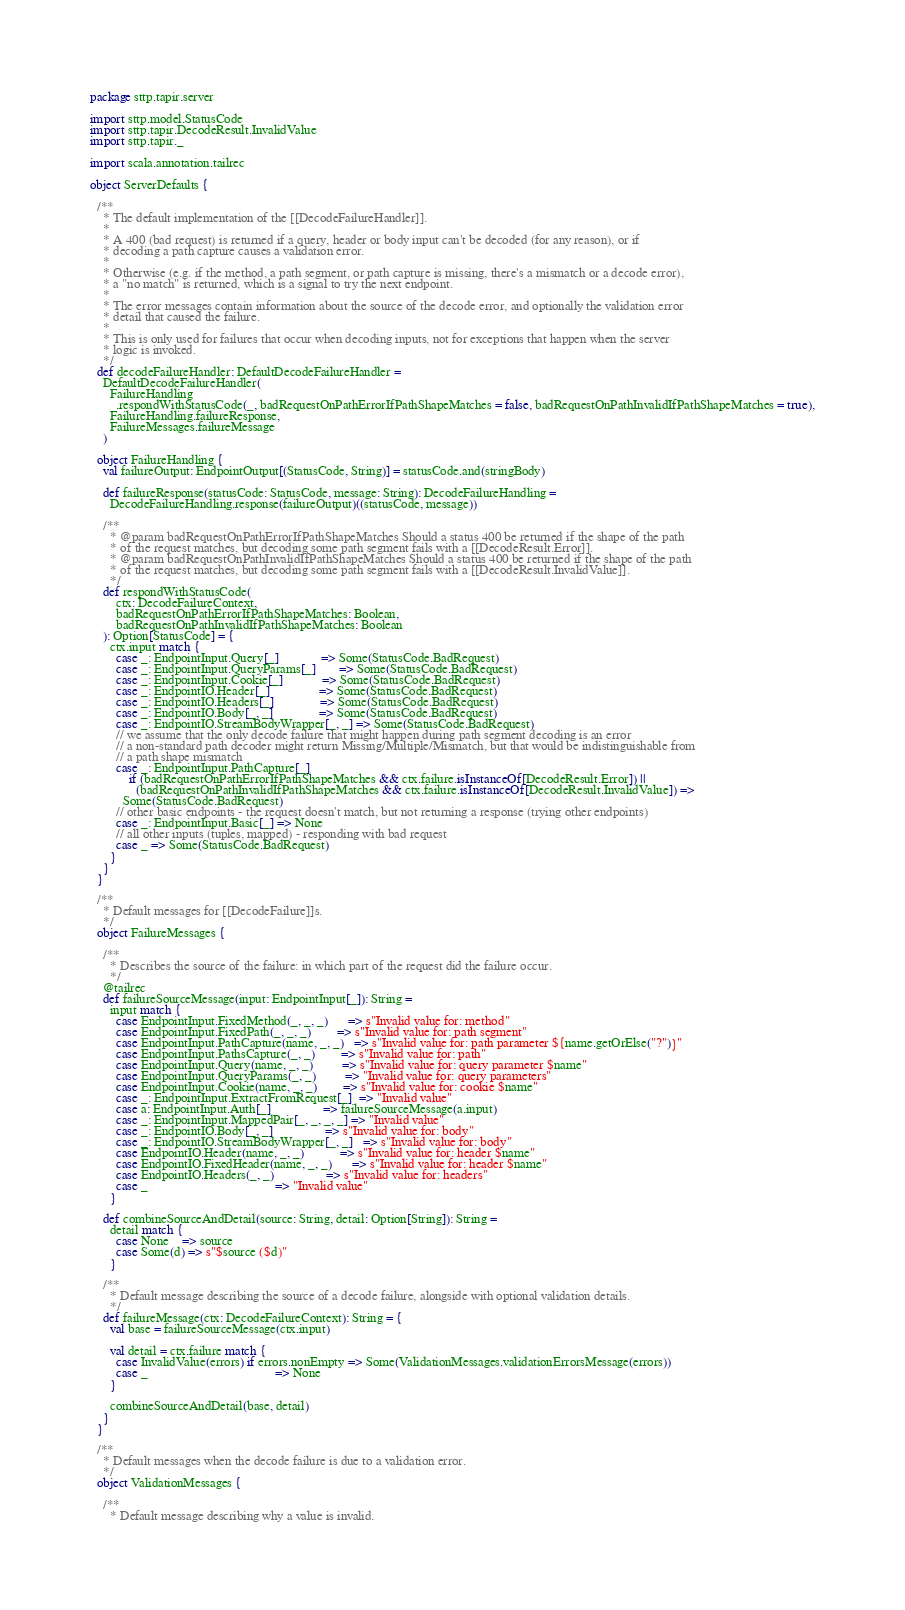Convert code to text. <code><loc_0><loc_0><loc_500><loc_500><_Scala_>package sttp.tapir.server

import sttp.model.StatusCode
import sttp.tapir.DecodeResult.InvalidValue
import sttp.tapir._

import scala.annotation.tailrec

object ServerDefaults {

  /**
    * The default implementation of the [[DecodeFailureHandler]].
    *
    * A 400 (bad request) is returned if a query, header or body input can't be decoded (for any reason), or if
    * decoding a path capture causes a validation error.
    *
    * Otherwise (e.g. if the method, a path segment, or path capture is missing, there's a mismatch or a decode error),
    * a "no match" is returned, which is a signal to try the next endpoint.
    *
    * The error messages contain information about the source of the decode error, and optionally the validation error
    * detail that caused the failure.
    *
    * This is only used for failures that occur when decoding inputs, not for exceptions that happen when the server
    * logic is invoked.
    */
  def decodeFailureHandler: DefaultDecodeFailureHandler =
    DefaultDecodeFailureHandler(
      FailureHandling
        .respondWithStatusCode(_, badRequestOnPathErrorIfPathShapeMatches = false, badRequestOnPathInvalidIfPathShapeMatches = true),
      FailureHandling.failureResponse,
      FailureMessages.failureMessage
    )

  object FailureHandling {
    val failureOutput: EndpointOutput[(StatusCode, String)] = statusCode.and(stringBody)

    def failureResponse(statusCode: StatusCode, message: String): DecodeFailureHandling =
      DecodeFailureHandling.response(failureOutput)((statusCode, message))

    /**
      * @param badRequestOnPathErrorIfPathShapeMatches Should a status 400 be returned if the shape of the path
      * of the request matches, but decoding some path segment fails with a [[DecodeResult.Error]].
      * @param badRequestOnPathInvalidIfPathShapeMatches Should a status 400 be returned if the shape of the path
      * of the request matches, but decoding some path segment fails with a [[DecodeResult.InvalidValue]].
      */
    def respondWithStatusCode(
        ctx: DecodeFailureContext,
        badRequestOnPathErrorIfPathShapeMatches: Boolean,
        badRequestOnPathInvalidIfPathShapeMatches: Boolean
    ): Option[StatusCode] = {
      ctx.input match {
        case _: EndpointInput.Query[_]             => Some(StatusCode.BadRequest)
        case _: EndpointInput.QueryParams[_]       => Some(StatusCode.BadRequest)
        case _: EndpointInput.Cookie[_]            => Some(StatusCode.BadRequest)
        case _: EndpointIO.Header[_]               => Some(StatusCode.BadRequest)
        case _: EndpointIO.Headers[_]              => Some(StatusCode.BadRequest)
        case _: EndpointIO.Body[_, _]              => Some(StatusCode.BadRequest)
        case _: EndpointIO.StreamBodyWrapper[_, _] => Some(StatusCode.BadRequest)
        // we assume that the only decode failure that might happen during path segment decoding is an error
        // a non-standard path decoder might return Missing/Multiple/Mismatch, but that would be indistinguishable from
        // a path shape mismatch
        case _: EndpointInput.PathCapture[_]
            if (badRequestOnPathErrorIfPathShapeMatches && ctx.failure.isInstanceOf[DecodeResult.Error]) ||
              (badRequestOnPathInvalidIfPathShapeMatches && ctx.failure.isInstanceOf[DecodeResult.InvalidValue]) =>
          Some(StatusCode.BadRequest)
        // other basic endpoints - the request doesn't match, but not returning a response (trying other endpoints)
        case _: EndpointInput.Basic[_] => None
        // all other inputs (tuples, mapped) - responding with bad request
        case _ => Some(StatusCode.BadRequest)
      }
    }
  }

  /**
    * Default messages for [[DecodeFailure]]s.
    */
  object FailureMessages {

    /**
      * Describes the source of the failure: in which part of the request did the failure occur.
      */
    @tailrec
    def failureSourceMessage(input: EndpointInput[_]): String =
      input match {
        case EndpointInput.FixedMethod(_, _, _)      => s"Invalid value for: method"
        case EndpointInput.FixedPath(_, _, _)        => s"Invalid value for: path segment"
        case EndpointInput.PathCapture(name, _, _)   => s"Invalid value for: path parameter ${name.getOrElse("?")}"
        case EndpointInput.PathsCapture(_, _)        => s"Invalid value for: path"
        case EndpointInput.Query(name, _, _)         => s"Invalid value for: query parameter $name"
        case EndpointInput.QueryParams(_, _)         => "Invalid value for: query parameters"
        case EndpointInput.Cookie(name, _, _)        => s"Invalid value for: cookie $name"
        case _: EndpointInput.ExtractFromRequest[_]  => "Invalid value"
        case a: EndpointInput.Auth[_]                => failureSourceMessage(a.input)
        case _: EndpointInput.MappedPair[_, _, _, _] => "Invalid value"
        case _: EndpointIO.Body[_, _]                => s"Invalid value for: body"
        case _: EndpointIO.StreamBodyWrapper[_, _]   => s"Invalid value for: body"
        case EndpointIO.Header(name, _, _)           => s"Invalid value for: header $name"
        case EndpointIO.FixedHeader(name, _, _)      => s"Invalid value for: header $name"
        case EndpointIO.Headers(_, _)                => s"Invalid value for: headers"
        case _                                       => "Invalid value"
      }

    def combineSourceAndDetail(source: String, detail: Option[String]): String =
      detail match {
        case None    => source
        case Some(d) => s"$source ($d)"
      }

    /**
      * Default message describing the source of a decode failure, alongside with optional validation details.
      */
    def failureMessage(ctx: DecodeFailureContext): String = {
      val base = failureSourceMessage(ctx.input)

      val detail = ctx.failure match {
        case InvalidValue(errors) if errors.nonEmpty => Some(ValidationMessages.validationErrorsMessage(errors))
        case _                                       => None
      }

      combineSourceAndDetail(base, detail)
    }
  }

  /**
    * Default messages when the decode failure is due to a validation error.
    */
  object ValidationMessages {

    /**
      * Default message describing why a value is invalid.</code> 